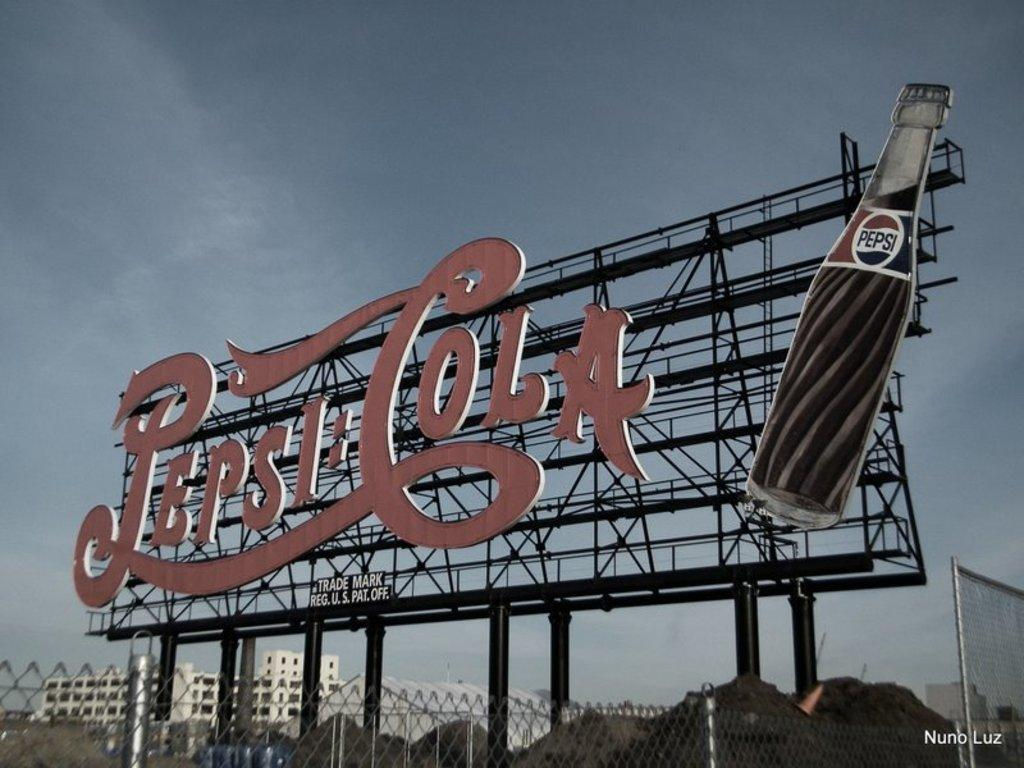<image>
Share a concise interpretation of the image provided. a pepsi cola billboard hangs on a shelf 